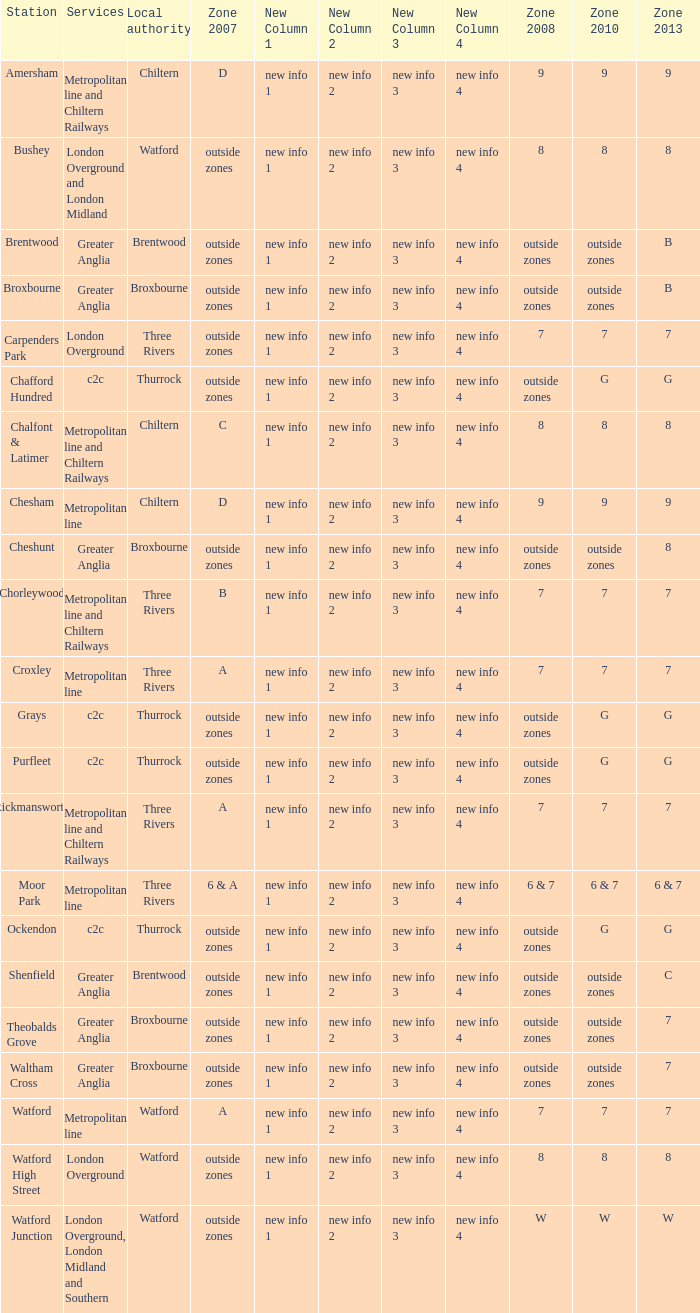Which Zone 2008 has Services of greater anglia, and a Station of cheshunt? Outside zones. 